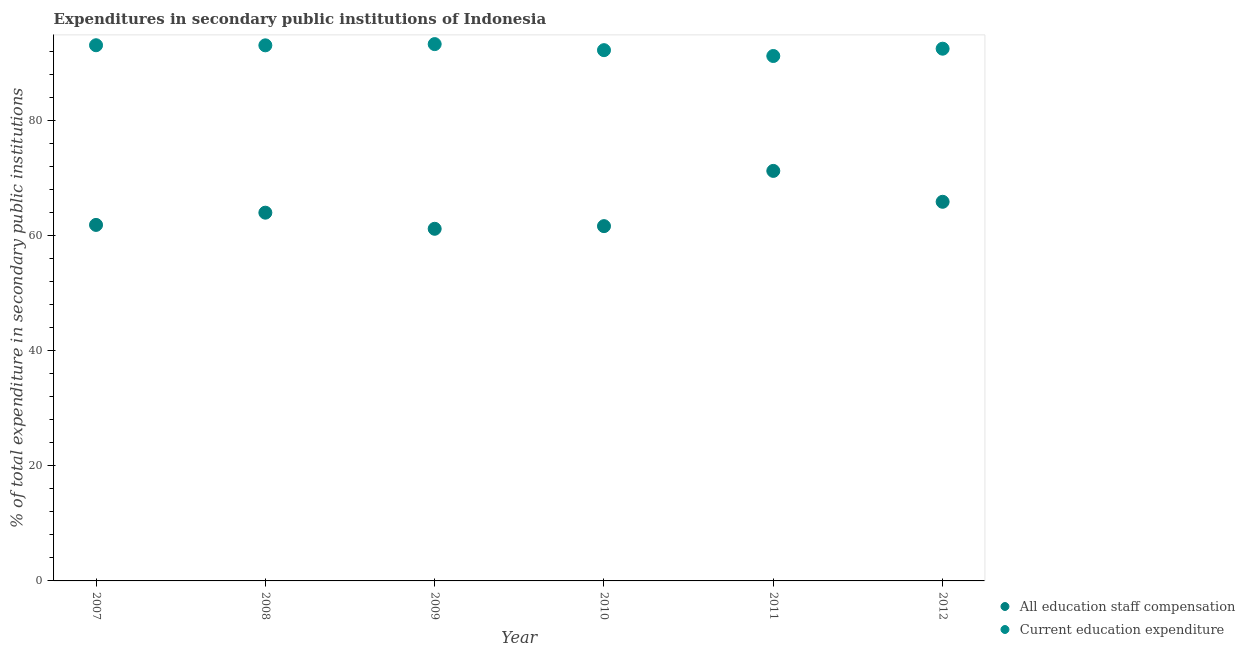What is the expenditure in staff compensation in 2011?
Keep it short and to the point. 71.31. Across all years, what is the maximum expenditure in education?
Give a very brief answer. 93.36. Across all years, what is the minimum expenditure in staff compensation?
Ensure brevity in your answer.  61.24. In which year was the expenditure in staff compensation maximum?
Provide a succinct answer. 2011. What is the total expenditure in staff compensation in the graph?
Your response must be concise. 386.14. What is the difference between the expenditure in staff compensation in 2007 and that in 2008?
Ensure brevity in your answer.  -2.13. What is the difference between the expenditure in staff compensation in 2007 and the expenditure in education in 2012?
Your response must be concise. -30.65. What is the average expenditure in education per year?
Provide a succinct answer. 92.64. In the year 2011, what is the difference between the expenditure in education and expenditure in staff compensation?
Offer a terse response. 19.98. What is the ratio of the expenditure in education in 2007 to that in 2008?
Offer a terse response. 1. Is the expenditure in education in 2010 less than that in 2011?
Keep it short and to the point. No. What is the difference between the highest and the second highest expenditure in staff compensation?
Ensure brevity in your answer.  5.37. What is the difference between the highest and the lowest expenditure in staff compensation?
Your response must be concise. 10.07. Does the graph contain any zero values?
Provide a short and direct response. No. Does the graph contain grids?
Your answer should be very brief. No. How many legend labels are there?
Provide a short and direct response. 2. How are the legend labels stacked?
Offer a very short reply. Vertical. What is the title of the graph?
Your answer should be very brief. Expenditures in secondary public institutions of Indonesia. What is the label or title of the X-axis?
Ensure brevity in your answer.  Year. What is the label or title of the Y-axis?
Ensure brevity in your answer.  % of total expenditure in secondary public institutions. What is the % of total expenditure in secondary public institutions in All education staff compensation in 2007?
Your answer should be very brief. 61.92. What is the % of total expenditure in secondary public institutions of Current education expenditure in 2007?
Your response must be concise. 93.16. What is the % of total expenditure in secondary public institutions of All education staff compensation in 2008?
Offer a terse response. 64.04. What is the % of total expenditure in secondary public institutions of Current education expenditure in 2008?
Give a very brief answer. 93.15. What is the % of total expenditure in secondary public institutions in All education staff compensation in 2009?
Provide a succinct answer. 61.24. What is the % of total expenditure in secondary public institutions in Current education expenditure in 2009?
Offer a terse response. 93.36. What is the % of total expenditure in secondary public institutions in All education staff compensation in 2010?
Keep it short and to the point. 61.7. What is the % of total expenditure in secondary public institutions in Current education expenditure in 2010?
Offer a terse response. 92.31. What is the % of total expenditure in secondary public institutions of All education staff compensation in 2011?
Your answer should be compact. 71.31. What is the % of total expenditure in secondary public institutions of Current education expenditure in 2011?
Offer a terse response. 91.29. What is the % of total expenditure in secondary public institutions in All education staff compensation in 2012?
Make the answer very short. 65.94. What is the % of total expenditure in secondary public institutions in Current education expenditure in 2012?
Keep it short and to the point. 92.56. Across all years, what is the maximum % of total expenditure in secondary public institutions in All education staff compensation?
Keep it short and to the point. 71.31. Across all years, what is the maximum % of total expenditure in secondary public institutions in Current education expenditure?
Provide a succinct answer. 93.36. Across all years, what is the minimum % of total expenditure in secondary public institutions in All education staff compensation?
Provide a succinct answer. 61.24. Across all years, what is the minimum % of total expenditure in secondary public institutions of Current education expenditure?
Make the answer very short. 91.29. What is the total % of total expenditure in secondary public institutions in All education staff compensation in the graph?
Provide a succinct answer. 386.14. What is the total % of total expenditure in secondary public institutions of Current education expenditure in the graph?
Ensure brevity in your answer.  555.82. What is the difference between the % of total expenditure in secondary public institutions in All education staff compensation in 2007 and that in 2008?
Offer a very short reply. -2.13. What is the difference between the % of total expenditure in secondary public institutions of Current education expenditure in 2007 and that in 2008?
Ensure brevity in your answer.  0.02. What is the difference between the % of total expenditure in secondary public institutions in All education staff compensation in 2007 and that in 2009?
Keep it short and to the point. 0.68. What is the difference between the % of total expenditure in secondary public institutions in Current education expenditure in 2007 and that in 2009?
Ensure brevity in your answer.  -0.2. What is the difference between the % of total expenditure in secondary public institutions of All education staff compensation in 2007 and that in 2010?
Your answer should be very brief. 0.21. What is the difference between the % of total expenditure in secondary public institutions of Current education expenditure in 2007 and that in 2010?
Your response must be concise. 0.85. What is the difference between the % of total expenditure in secondary public institutions of All education staff compensation in 2007 and that in 2011?
Your answer should be very brief. -9.39. What is the difference between the % of total expenditure in secondary public institutions of Current education expenditure in 2007 and that in 2011?
Provide a short and direct response. 1.87. What is the difference between the % of total expenditure in secondary public institutions in All education staff compensation in 2007 and that in 2012?
Ensure brevity in your answer.  -4.02. What is the difference between the % of total expenditure in secondary public institutions of Current education expenditure in 2007 and that in 2012?
Your answer should be very brief. 0.6. What is the difference between the % of total expenditure in secondary public institutions of All education staff compensation in 2008 and that in 2009?
Offer a very short reply. 2.8. What is the difference between the % of total expenditure in secondary public institutions in Current education expenditure in 2008 and that in 2009?
Your answer should be compact. -0.21. What is the difference between the % of total expenditure in secondary public institutions in All education staff compensation in 2008 and that in 2010?
Ensure brevity in your answer.  2.34. What is the difference between the % of total expenditure in secondary public institutions in Current education expenditure in 2008 and that in 2010?
Provide a short and direct response. 0.84. What is the difference between the % of total expenditure in secondary public institutions in All education staff compensation in 2008 and that in 2011?
Ensure brevity in your answer.  -7.26. What is the difference between the % of total expenditure in secondary public institutions of Current education expenditure in 2008 and that in 2011?
Give a very brief answer. 1.85. What is the difference between the % of total expenditure in secondary public institutions in All education staff compensation in 2008 and that in 2012?
Offer a terse response. -1.89. What is the difference between the % of total expenditure in secondary public institutions in Current education expenditure in 2008 and that in 2012?
Provide a succinct answer. 0.58. What is the difference between the % of total expenditure in secondary public institutions in All education staff compensation in 2009 and that in 2010?
Your answer should be compact. -0.46. What is the difference between the % of total expenditure in secondary public institutions in Current education expenditure in 2009 and that in 2010?
Your response must be concise. 1.05. What is the difference between the % of total expenditure in secondary public institutions in All education staff compensation in 2009 and that in 2011?
Your response must be concise. -10.07. What is the difference between the % of total expenditure in secondary public institutions in Current education expenditure in 2009 and that in 2011?
Your response must be concise. 2.07. What is the difference between the % of total expenditure in secondary public institutions of All education staff compensation in 2009 and that in 2012?
Make the answer very short. -4.7. What is the difference between the % of total expenditure in secondary public institutions in Current education expenditure in 2009 and that in 2012?
Keep it short and to the point. 0.8. What is the difference between the % of total expenditure in secondary public institutions in All education staff compensation in 2010 and that in 2011?
Ensure brevity in your answer.  -9.61. What is the difference between the % of total expenditure in secondary public institutions of Current education expenditure in 2010 and that in 2011?
Give a very brief answer. 1.02. What is the difference between the % of total expenditure in secondary public institutions in All education staff compensation in 2010 and that in 2012?
Offer a terse response. -4.23. What is the difference between the % of total expenditure in secondary public institutions in Current education expenditure in 2010 and that in 2012?
Offer a very short reply. -0.25. What is the difference between the % of total expenditure in secondary public institutions in All education staff compensation in 2011 and that in 2012?
Provide a short and direct response. 5.37. What is the difference between the % of total expenditure in secondary public institutions in Current education expenditure in 2011 and that in 2012?
Your answer should be compact. -1.27. What is the difference between the % of total expenditure in secondary public institutions of All education staff compensation in 2007 and the % of total expenditure in secondary public institutions of Current education expenditure in 2008?
Provide a short and direct response. -31.23. What is the difference between the % of total expenditure in secondary public institutions of All education staff compensation in 2007 and the % of total expenditure in secondary public institutions of Current education expenditure in 2009?
Make the answer very short. -31.44. What is the difference between the % of total expenditure in secondary public institutions in All education staff compensation in 2007 and the % of total expenditure in secondary public institutions in Current education expenditure in 2010?
Your answer should be compact. -30.39. What is the difference between the % of total expenditure in secondary public institutions of All education staff compensation in 2007 and the % of total expenditure in secondary public institutions of Current education expenditure in 2011?
Provide a succinct answer. -29.38. What is the difference between the % of total expenditure in secondary public institutions of All education staff compensation in 2007 and the % of total expenditure in secondary public institutions of Current education expenditure in 2012?
Provide a succinct answer. -30.65. What is the difference between the % of total expenditure in secondary public institutions in All education staff compensation in 2008 and the % of total expenditure in secondary public institutions in Current education expenditure in 2009?
Your answer should be very brief. -29.32. What is the difference between the % of total expenditure in secondary public institutions of All education staff compensation in 2008 and the % of total expenditure in secondary public institutions of Current education expenditure in 2010?
Offer a very short reply. -28.26. What is the difference between the % of total expenditure in secondary public institutions in All education staff compensation in 2008 and the % of total expenditure in secondary public institutions in Current education expenditure in 2011?
Your answer should be very brief. -27.25. What is the difference between the % of total expenditure in secondary public institutions in All education staff compensation in 2008 and the % of total expenditure in secondary public institutions in Current education expenditure in 2012?
Make the answer very short. -28.52. What is the difference between the % of total expenditure in secondary public institutions of All education staff compensation in 2009 and the % of total expenditure in secondary public institutions of Current education expenditure in 2010?
Ensure brevity in your answer.  -31.07. What is the difference between the % of total expenditure in secondary public institutions of All education staff compensation in 2009 and the % of total expenditure in secondary public institutions of Current education expenditure in 2011?
Your answer should be very brief. -30.05. What is the difference between the % of total expenditure in secondary public institutions of All education staff compensation in 2009 and the % of total expenditure in secondary public institutions of Current education expenditure in 2012?
Keep it short and to the point. -31.32. What is the difference between the % of total expenditure in secondary public institutions in All education staff compensation in 2010 and the % of total expenditure in secondary public institutions in Current education expenditure in 2011?
Keep it short and to the point. -29.59. What is the difference between the % of total expenditure in secondary public institutions of All education staff compensation in 2010 and the % of total expenditure in secondary public institutions of Current education expenditure in 2012?
Give a very brief answer. -30.86. What is the difference between the % of total expenditure in secondary public institutions of All education staff compensation in 2011 and the % of total expenditure in secondary public institutions of Current education expenditure in 2012?
Offer a terse response. -21.25. What is the average % of total expenditure in secondary public institutions in All education staff compensation per year?
Offer a very short reply. 64.36. What is the average % of total expenditure in secondary public institutions in Current education expenditure per year?
Your answer should be very brief. 92.64. In the year 2007, what is the difference between the % of total expenditure in secondary public institutions of All education staff compensation and % of total expenditure in secondary public institutions of Current education expenditure?
Your answer should be very brief. -31.25. In the year 2008, what is the difference between the % of total expenditure in secondary public institutions of All education staff compensation and % of total expenditure in secondary public institutions of Current education expenditure?
Keep it short and to the point. -29.1. In the year 2009, what is the difference between the % of total expenditure in secondary public institutions of All education staff compensation and % of total expenditure in secondary public institutions of Current education expenditure?
Your answer should be compact. -32.12. In the year 2010, what is the difference between the % of total expenditure in secondary public institutions in All education staff compensation and % of total expenditure in secondary public institutions in Current education expenditure?
Provide a succinct answer. -30.61. In the year 2011, what is the difference between the % of total expenditure in secondary public institutions of All education staff compensation and % of total expenditure in secondary public institutions of Current education expenditure?
Your answer should be very brief. -19.98. In the year 2012, what is the difference between the % of total expenditure in secondary public institutions in All education staff compensation and % of total expenditure in secondary public institutions in Current education expenditure?
Offer a very short reply. -26.63. What is the ratio of the % of total expenditure in secondary public institutions of All education staff compensation in 2007 to that in 2008?
Provide a succinct answer. 0.97. What is the ratio of the % of total expenditure in secondary public institutions of Current education expenditure in 2007 to that in 2008?
Give a very brief answer. 1. What is the ratio of the % of total expenditure in secondary public institutions in All education staff compensation in 2007 to that in 2010?
Give a very brief answer. 1. What is the ratio of the % of total expenditure in secondary public institutions of Current education expenditure in 2007 to that in 2010?
Offer a terse response. 1.01. What is the ratio of the % of total expenditure in secondary public institutions in All education staff compensation in 2007 to that in 2011?
Ensure brevity in your answer.  0.87. What is the ratio of the % of total expenditure in secondary public institutions of Current education expenditure in 2007 to that in 2011?
Your answer should be very brief. 1.02. What is the ratio of the % of total expenditure in secondary public institutions in All education staff compensation in 2007 to that in 2012?
Your answer should be very brief. 0.94. What is the ratio of the % of total expenditure in secondary public institutions in All education staff compensation in 2008 to that in 2009?
Give a very brief answer. 1.05. What is the ratio of the % of total expenditure in secondary public institutions in All education staff compensation in 2008 to that in 2010?
Provide a succinct answer. 1.04. What is the ratio of the % of total expenditure in secondary public institutions in Current education expenditure in 2008 to that in 2010?
Your answer should be compact. 1.01. What is the ratio of the % of total expenditure in secondary public institutions in All education staff compensation in 2008 to that in 2011?
Your answer should be very brief. 0.9. What is the ratio of the % of total expenditure in secondary public institutions in Current education expenditure in 2008 to that in 2011?
Provide a succinct answer. 1.02. What is the ratio of the % of total expenditure in secondary public institutions of All education staff compensation in 2008 to that in 2012?
Offer a very short reply. 0.97. What is the ratio of the % of total expenditure in secondary public institutions in Current education expenditure in 2008 to that in 2012?
Give a very brief answer. 1.01. What is the ratio of the % of total expenditure in secondary public institutions in All education staff compensation in 2009 to that in 2010?
Your answer should be compact. 0.99. What is the ratio of the % of total expenditure in secondary public institutions of Current education expenditure in 2009 to that in 2010?
Provide a short and direct response. 1.01. What is the ratio of the % of total expenditure in secondary public institutions in All education staff compensation in 2009 to that in 2011?
Keep it short and to the point. 0.86. What is the ratio of the % of total expenditure in secondary public institutions in Current education expenditure in 2009 to that in 2011?
Your answer should be compact. 1.02. What is the ratio of the % of total expenditure in secondary public institutions of All education staff compensation in 2009 to that in 2012?
Ensure brevity in your answer.  0.93. What is the ratio of the % of total expenditure in secondary public institutions in Current education expenditure in 2009 to that in 2012?
Offer a terse response. 1.01. What is the ratio of the % of total expenditure in secondary public institutions in All education staff compensation in 2010 to that in 2011?
Offer a terse response. 0.87. What is the ratio of the % of total expenditure in secondary public institutions in Current education expenditure in 2010 to that in 2011?
Ensure brevity in your answer.  1.01. What is the ratio of the % of total expenditure in secondary public institutions in All education staff compensation in 2010 to that in 2012?
Ensure brevity in your answer.  0.94. What is the ratio of the % of total expenditure in secondary public institutions in All education staff compensation in 2011 to that in 2012?
Give a very brief answer. 1.08. What is the ratio of the % of total expenditure in secondary public institutions in Current education expenditure in 2011 to that in 2012?
Give a very brief answer. 0.99. What is the difference between the highest and the second highest % of total expenditure in secondary public institutions of All education staff compensation?
Keep it short and to the point. 5.37. What is the difference between the highest and the second highest % of total expenditure in secondary public institutions in Current education expenditure?
Ensure brevity in your answer.  0.2. What is the difference between the highest and the lowest % of total expenditure in secondary public institutions of All education staff compensation?
Offer a very short reply. 10.07. What is the difference between the highest and the lowest % of total expenditure in secondary public institutions of Current education expenditure?
Your answer should be very brief. 2.07. 